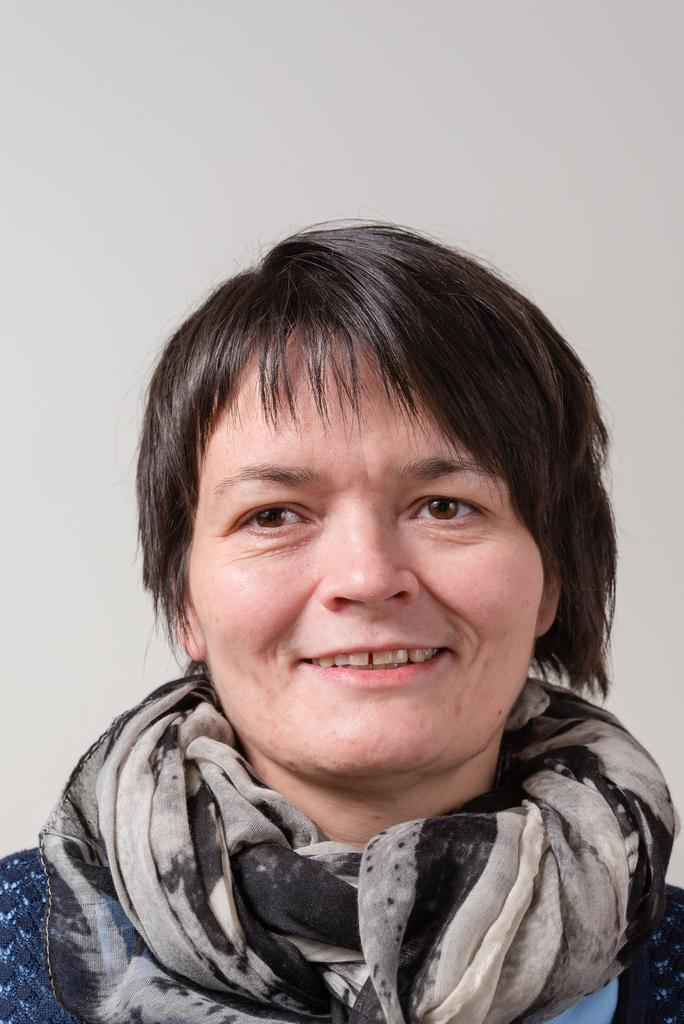What is the main subject of the image? There is a woman's face in the center of the image. What can be seen in the background of the image? There is a wall in the background of the image. How many cats are sitting on the woman's head in the image? There are no cats present in the image. What type of stamp is visible on the woman's forehead in the image? There is no stamp visible on the woman's forehead in the image. 